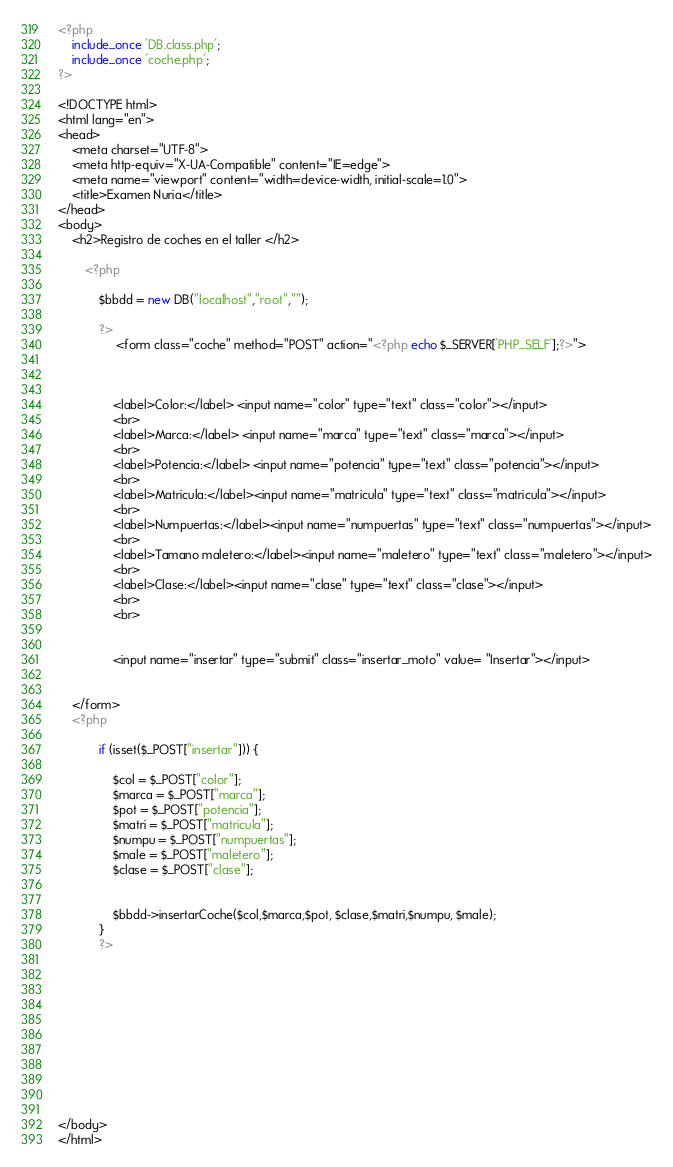<code> <loc_0><loc_0><loc_500><loc_500><_PHP_><?php
    include_once 'DB.class.php';
    include_once 'coche.php';
?>

<!DOCTYPE html>
<html lang="en">
<head>
    <meta charset="UTF-8">
    <meta http-equiv="X-UA-Compatible" content="IE=edge">
    <meta name="viewport" content="width=device-width, initial-scale=1.0">
    <title>Examen Nuria</title>
</head>
<body>
    <h2>Registro de coches en el taller </h2>
    
        <?php
            
            $bbdd = new DB("localhost","root","");
                
            ?>
                 <form class="coche" method="POST" action="<?php echo $_SERVER['PHP_SELF'];?>">
                   
               

				<label>Color:</label> <input name="color" type="text" class="color"></input>
				<br>
				<label>Marca:</label> <input name="marca" type="text" class="marca"></input>
				<br>
				<label>Potencia:</label> <input name="potencia" type="text" class="potencia"></input>
				<br>
				<label>Matricula:</label><input name="matricula" type="text" class="matricula"></input>
				<br>
                <label>Numpuertas:</label><input name="numpuertas" type="text" class="numpuertas"></input>
				<br>
                <label>Tamano maletero:</label><input name="maletero" type="text" class="maletero"></input>
				<br>
                <label>Clase:</label><input name="clase" type="text" class="clase"></input>
				<br>
 				<br>
				
				
				<input name="insertar" type="submit" class="insertar_moto" value= "Insertar"></input>
        

    </form>
    <?php
            
            if (isset($_POST["insertar"])) {
                
                $col = $_POST["color"];
                $marca = $_POST["marca"];
                $pot = $_POST["potencia"];
                $matri = $_POST["matricula"];
                $numpu = $_POST["numpuertas"];
                $male = $_POST["maletero"];
                $clase = $_POST["clase"];
                
                
                $bbdd->insertarCoche($col,$marca,$pot, $clase,$matri,$numpu, $male);
            }
            ?>











</body>
</html></code> 